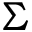<formula> <loc_0><loc_0><loc_500><loc_500>\Sigma</formula> 